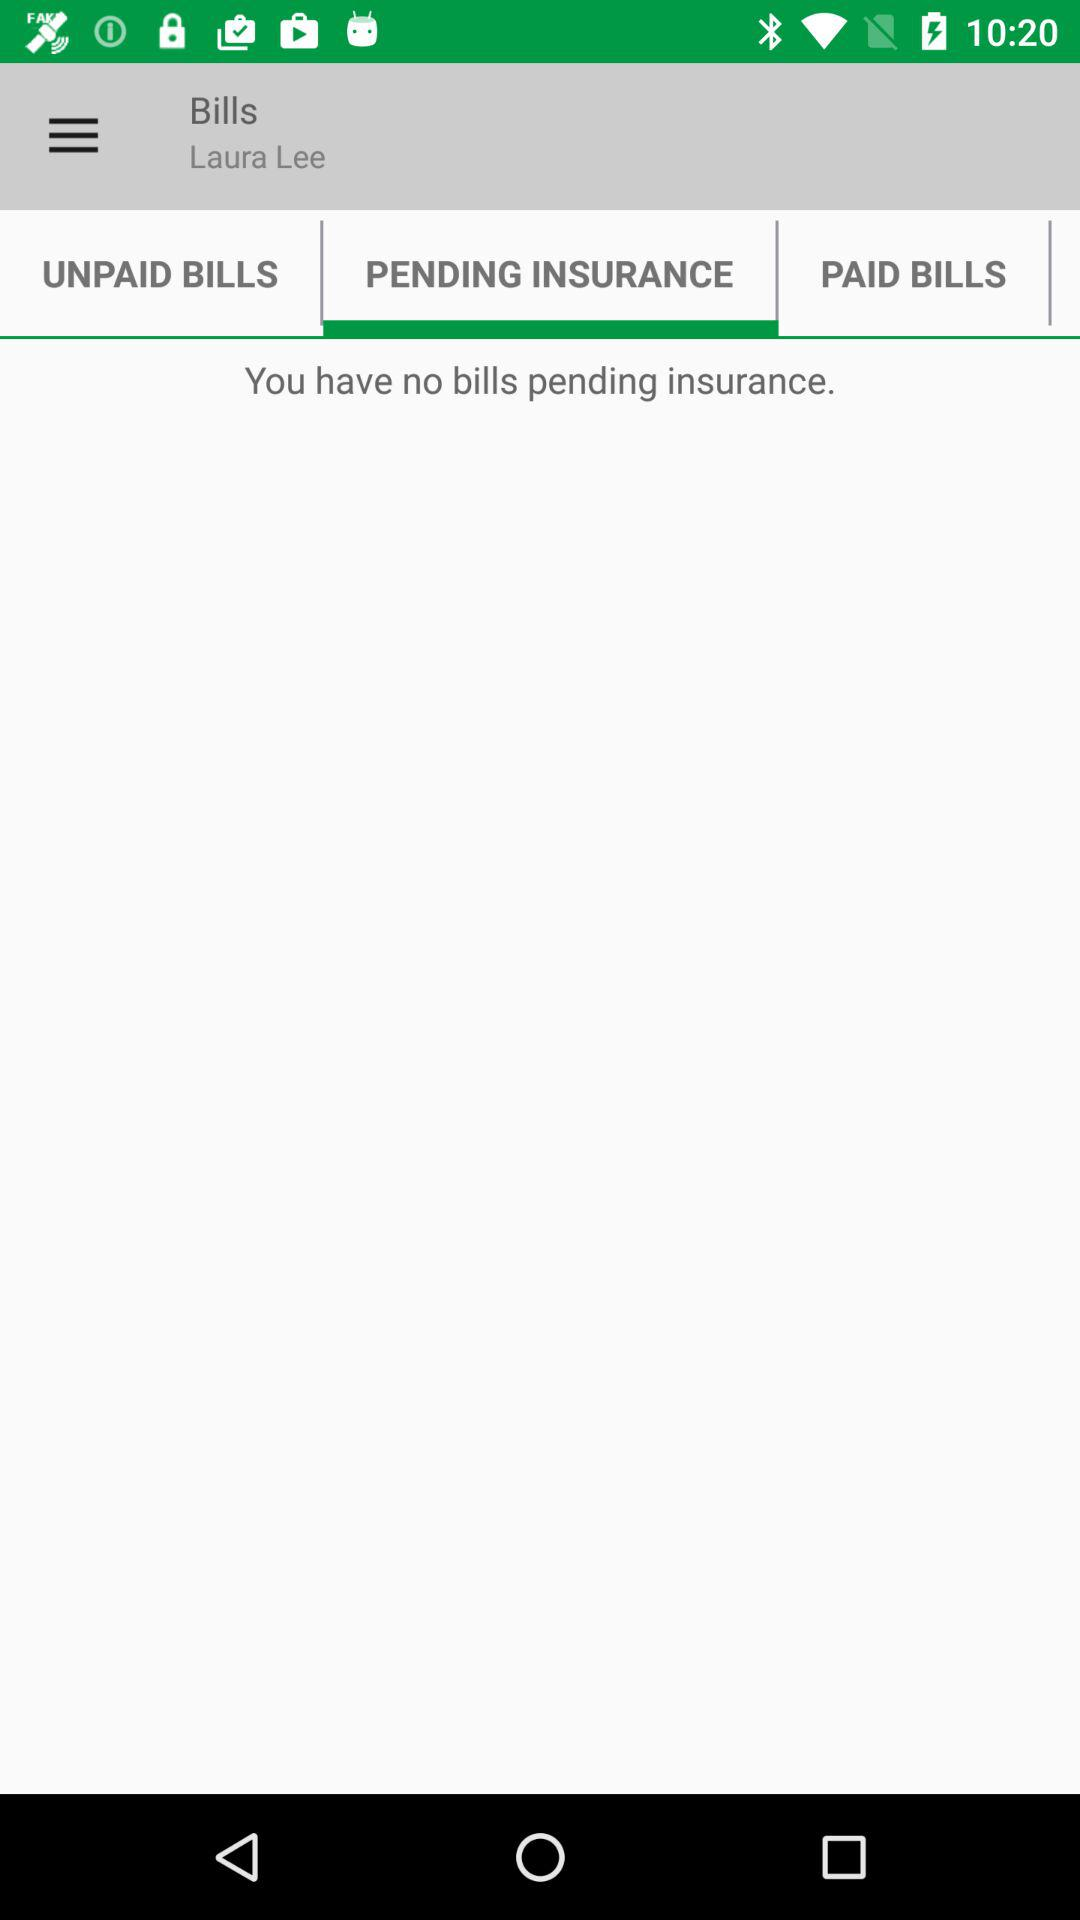What is the name of the user? The name of the user is Laura Lee. 